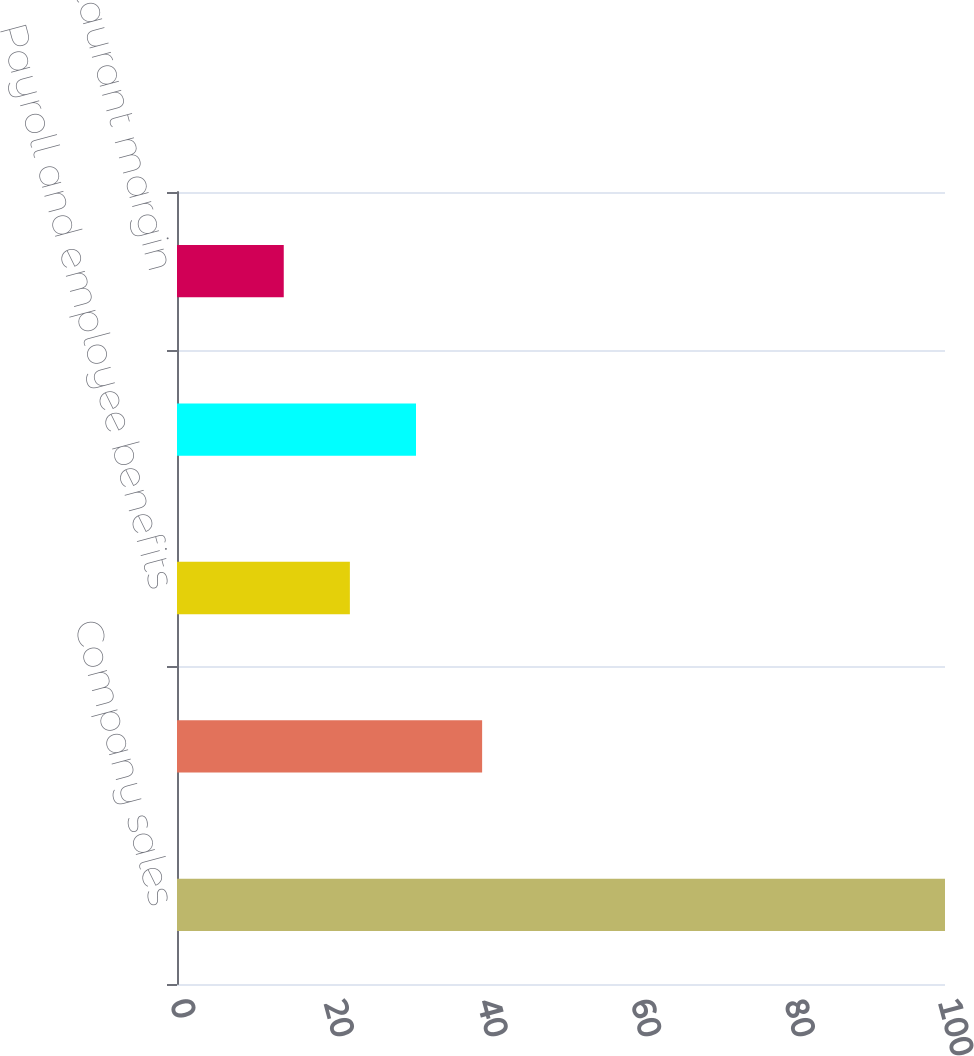Convert chart to OTSL. <chart><loc_0><loc_0><loc_500><loc_500><bar_chart><fcel>Company sales<fcel>Food and paper<fcel>Payroll and employee benefits<fcel>Occupancy and other operating<fcel>Company restaurant margin<nl><fcel>100<fcel>39.73<fcel>22.51<fcel>31.12<fcel>13.9<nl></chart> 